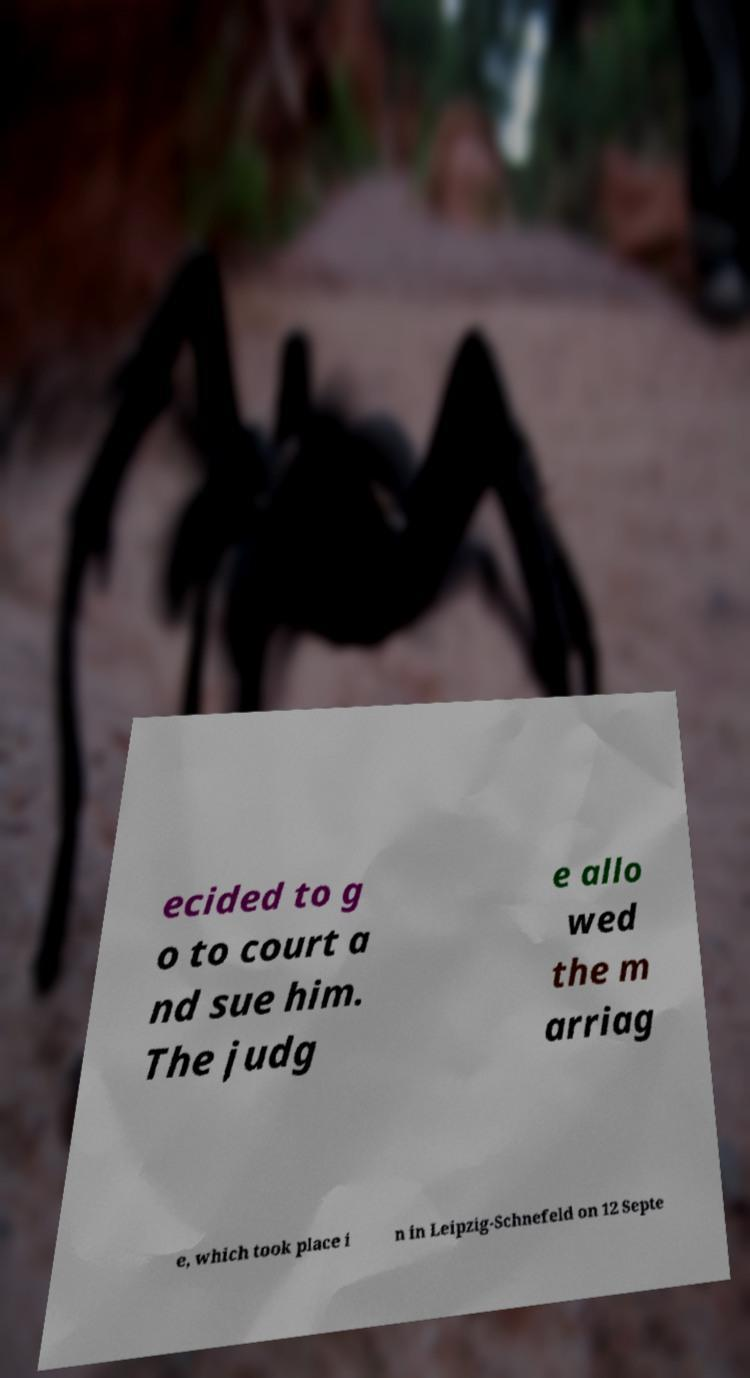Can you read and provide the text displayed in the image?This photo seems to have some interesting text. Can you extract and type it out for me? ecided to g o to court a nd sue him. The judg e allo wed the m arriag e, which took place i n in Leipzig-Schnefeld on 12 Septe 